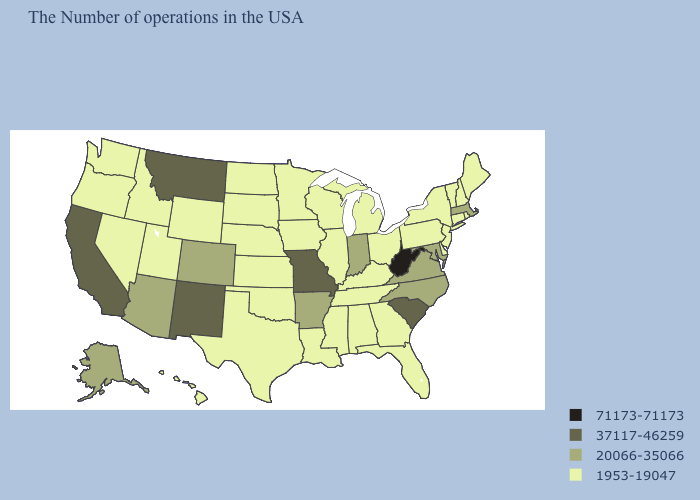Name the states that have a value in the range 20066-35066?
Be succinct. Massachusetts, Maryland, Virginia, North Carolina, Indiana, Arkansas, Colorado, Arizona, Alaska. Name the states that have a value in the range 37117-46259?
Short answer required. South Carolina, Missouri, New Mexico, Montana, California. What is the value of Minnesota?
Give a very brief answer. 1953-19047. Which states have the lowest value in the MidWest?
Write a very short answer. Ohio, Michigan, Wisconsin, Illinois, Minnesota, Iowa, Kansas, Nebraska, South Dakota, North Dakota. Does Oklahoma have a higher value than Ohio?
Keep it brief. No. Does Massachusetts have the highest value in the Northeast?
Be succinct. Yes. What is the highest value in states that border Maine?
Quick response, please. 1953-19047. What is the highest value in states that border Maryland?
Keep it brief. 71173-71173. Which states hav the highest value in the West?
Short answer required. New Mexico, Montana, California. Name the states that have a value in the range 1953-19047?
Be succinct. Maine, Rhode Island, New Hampshire, Vermont, Connecticut, New York, New Jersey, Delaware, Pennsylvania, Ohio, Florida, Georgia, Michigan, Kentucky, Alabama, Tennessee, Wisconsin, Illinois, Mississippi, Louisiana, Minnesota, Iowa, Kansas, Nebraska, Oklahoma, Texas, South Dakota, North Dakota, Wyoming, Utah, Idaho, Nevada, Washington, Oregon, Hawaii. Does Connecticut have the same value as Vermont?
Answer briefly. Yes. How many symbols are there in the legend?
Be succinct. 4. Does Montana have the lowest value in the West?
Give a very brief answer. No. Name the states that have a value in the range 20066-35066?
Quick response, please. Massachusetts, Maryland, Virginia, North Carolina, Indiana, Arkansas, Colorado, Arizona, Alaska. 